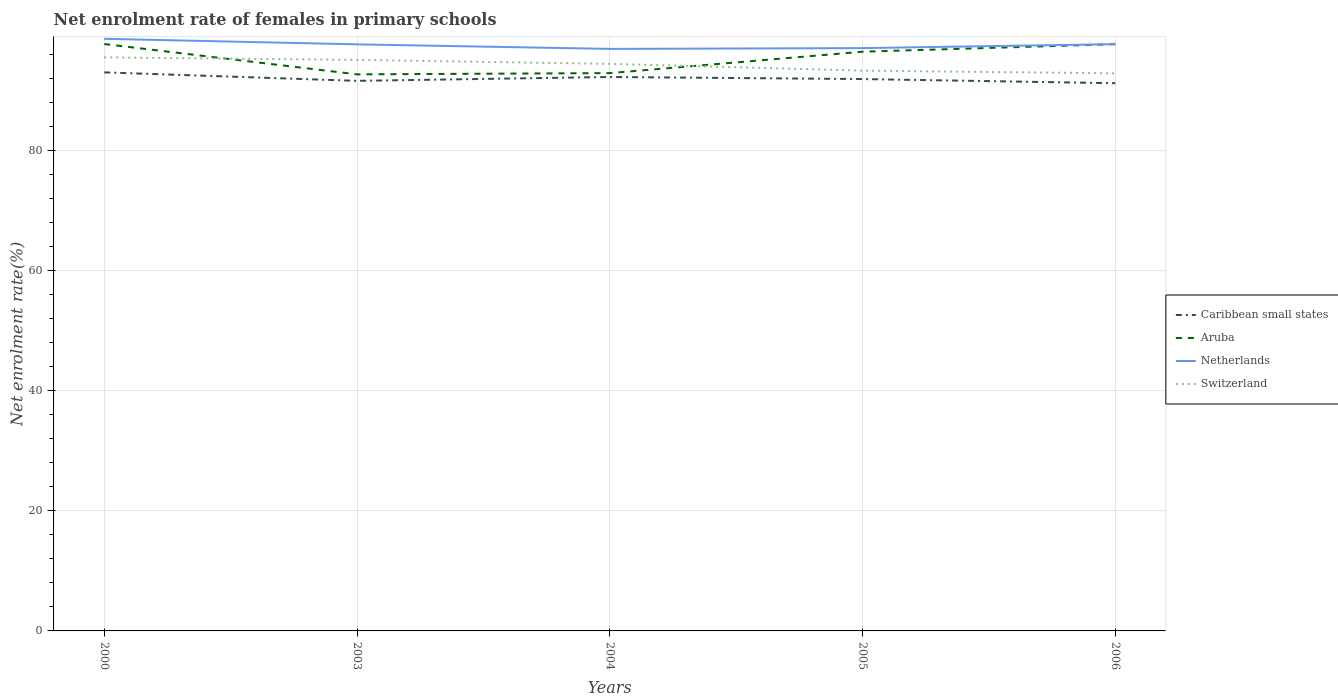Across all years, what is the maximum net enrolment rate of females in primary schools in Netherlands?
Provide a succinct answer. 97.01. What is the total net enrolment rate of females in primary schools in Switzerland in the graph?
Your response must be concise. 2.21. What is the difference between the highest and the second highest net enrolment rate of females in primary schools in Caribbean small states?
Your answer should be compact. 1.8. How many lines are there?
Ensure brevity in your answer.  4. What is the difference between two consecutive major ticks on the Y-axis?
Your answer should be very brief. 20. Are the values on the major ticks of Y-axis written in scientific E-notation?
Keep it short and to the point. No. Does the graph contain grids?
Keep it short and to the point. Yes. How many legend labels are there?
Provide a succinct answer. 4. How are the legend labels stacked?
Your answer should be very brief. Vertical. What is the title of the graph?
Provide a succinct answer. Net enrolment rate of females in primary schools. What is the label or title of the X-axis?
Make the answer very short. Years. What is the label or title of the Y-axis?
Make the answer very short. Net enrolment rate(%). What is the Net enrolment rate(%) of Caribbean small states in 2000?
Offer a terse response. 93.1. What is the Net enrolment rate(%) of Aruba in 2000?
Ensure brevity in your answer.  97.82. What is the Net enrolment rate(%) in Netherlands in 2000?
Provide a short and direct response. 98.69. What is the Net enrolment rate(%) of Switzerland in 2000?
Provide a succinct answer. 95.6. What is the Net enrolment rate(%) of Caribbean small states in 2003?
Keep it short and to the point. 91.69. What is the Net enrolment rate(%) of Aruba in 2003?
Your answer should be compact. 92.77. What is the Net enrolment rate(%) of Netherlands in 2003?
Your response must be concise. 97.77. What is the Net enrolment rate(%) in Switzerland in 2003?
Your answer should be very brief. 95.18. What is the Net enrolment rate(%) of Caribbean small states in 2004?
Keep it short and to the point. 92.33. What is the Net enrolment rate(%) in Aruba in 2004?
Your answer should be compact. 92.98. What is the Net enrolment rate(%) in Netherlands in 2004?
Provide a short and direct response. 97.01. What is the Net enrolment rate(%) of Switzerland in 2004?
Offer a very short reply. 94.52. What is the Net enrolment rate(%) of Caribbean small states in 2005?
Provide a short and direct response. 91.98. What is the Net enrolment rate(%) of Aruba in 2005?
Your answer should be very brief. 96.54. What is the Net enrolment rate(%) in Netherlands in 2005?
Provide a short and direct response. 97.14. What is the Net enrolment rate(%) of Switzerland in 2005?
Provide a short and direct response. 93.39. What is the Net enrolment rate(%) of Caribbean small states in 2006?
Offer a very short reply. 91.29. What is the Net enrolment rate(%) in Aruba in 2006?
Your response must be concise. 97.8. What is the Net enrolment rate(%) in Netherlands in 2006?
Offer a terse response. 97.8. What is the Net enrolment rate(%) of Switzerland in 2006?
Provide a short and direct response. 92.94. Across all years, what is the maximum Net enrolment rate(%) in Caribbean small states?
Give a very brief answer. 93.1. Across all years, what is the maximum Net enrolment rate(%) in Aruba?
Offer a terse response. 97.82. Across all years, what is the maximum Net enrolment rate(%) of Netherlands?
Ensure brevity in your answer.  98.69. Across all years, what is the maximum Net enrolment rate(%) in Switzerland?
Make the answer very short. 95.6. Across all years, what is the minimum Net enrolment rate(%) of Caribbean small states?
Make the answer very short. 91.29. Across all years, what is the minimum Net enrolment rate(%) of Aruba?
Your answer should be compact. 92.77. Across all years, what is the minimum Net enrolment rate(%) in Netherlands?
Ensure brevity in your answer.  97.01. Across all years, what is the minimum Net enrolment rate(%) in Switzerland?
Your response must be concise. 92.94. What is the total Net enrolment rate(%) in Caribbean small states in the graph?
Make the answer very short. 460.39. What is the total Net enrolment rate(%) of Aruba in the graph?
Your response must be concise. 477.91. What is the total Net enrolment rate(%) in Netherlands in the graph?
Make the answer very short. 488.42. What is the total Net enrolment rate(%) of Switzerland in the graph?
Offer a very short reply. 471.62. What is the difference between the Net enrolment rate(%) in Caribbean small states in 2000 and that in 2003?
Give a very brief answer. 1.41. What is the difference between the Net enrolment rate(%) in Aruba in 2000 and that in 2003?
Offer a very short reply. 5.05. What is the difference between the Net enrolment rate(%) of Netherlands in 2000 and that in 2003?
Offer a very short reply. 0.92. What is the difference between the Net enrolment rate(%) in Switzerland in 2000 and that in 2003?
Your response must be concise. 0.42. What is the difference between the Net enrolment rate(%) of Caribbean small states in 2000 and that in 2004?
Give a very brief answer. 0.77. What is the difference between the Net enrolment rate(%) in Aruba in 2000 and that in 2004?
Offer a terse response. 4.85. What is the difference between the Net enrolment rate(%) in Netherlands in 2000 and that in 2004?
Your answer should be very brief. 1.68. What is the difference between the Net enrolment rate(%) in Switzerland in 2000 and that in 2004?
Make the answer very short. 1.08. What is the difference between the Net enrolment rate(%) of Caribbean small states in 2000 and that in 2005?
Your response must be concise. 1.11. What is the difference between the Net enrolment rate(%) in Aruba in 2000 and that in 2005?
Ensure brevity in your answer.  1.28. What is the difference between the Net enrolment rate(%) in Netherlands in 2000 and that in 2005?
Ensure brevity in your answer.  1.55. What is the difference between the Net enrolment rate(%) in Switzerland in 2000 and that in 2005?
Offer a terse response. 2.21. What is the difference between the Net enrolment rate(%) of Caribbean small states in 2000 and that in 2006?
Ensure brevity in your answer.  1.8. What is the difference between the Net enrolment rate(%) in Aruba in 2000 and that in 2006?
Ensure brevity in your answer.  0.03. What is the difference between the Net enrolment rate(%) of Netherlands in 2000 and that in 2006?
Offer a very short reply. 0.89. What is the difference between the Net enrolment rate(%) in Switzerland in 2000 and that in 2006?
Provide a short and direct response. 2.66. What is the difference between the Net enrolment rate(%) of Caribbean small states in 2003 and that in 2004?
Your response must be concise. -0.64. What is the difference between the Net enrolment rate(%) of Aruba in 2003 and that in 2004?
Make the answer very short. -0.21. What is the difference between the Net enrolment rate(%) in Netherlands in 2003 and that in 2004?
Ensure brevity in your answer.  0.76. What is the difference between the Net enrolment rate(%) of Switzerland in 2003 and that in 2004?
Your answer should be compact. 0.66. What is the difference between the Net enrolment rate(%) of Caribbean small states in 2003 and that in 2005?
Make the answer very short. -0.3. What is the difference between the Net enrolment rate(%) in Aruba in 2003 and that in 2005?
Make the answer very short. -3.77. What is the difference between the Net enrolment rate(%) in Netherlands in 2003 and that in 2005?
Ensure brevity in your answer.  0.63. What is the difference between the Net enrolment rate(%) in Switzerland in 2003 and that in 2005?
Keep it short and to the point. 1.79. What is the difference between the Net enrolment rate(%) of Caribbean small states in 2003 and that in 2006?
Offer a terse response. 0.39. What is the difference between the Net enrolment rate(%) in Aruba in 2003 and that in 2006?
Provide a short and direct response. -5.03. What is the difference between the Net enrolment rate(%) of Netherlands in 2003 and that in 2006?
Make the answer very short. -0.03. What is the difference between the Net enrolment rate(%) in Switzerland in 2003 and that in 2006?
Make the answer very short. 2.24. What is the difference between the Net enrolment rate(%) of Caribbean small states in 2004 and that in 2005?
Your answer should be very brief. 0.35. What is the difference between the Net enrolment rate(%) of Aruba in 2004 and that in 2005?
Your response must be concise. -3.57. What is the difference between the Net enrolment rate(%) in Netherlands in 2004 and that in 2005?
Offer a very short reply. -0.13. What is the difference between the Net enrolment rate(%) of Switzerland in 2004 and that in 2005?
Offer a very short reply. 1.13. What is the difference between the Net enrolment rate(%) of Caribbean small states in 2004 and that in 2006?
Provide a short and direct response. 1.03. What is the difference between the Net enrolment rate(%) in Aruba in 2004 and that in 2006?
Make the answer very short. -4.82. What is the difference between the Net enrolment rate(%) in Netherlands in 2004 and that in 2006?
Your response must be concise. -0.79. What is the difference between the Net enrolment rate(%) in Switzerland in 2004 and that in 2006?
Provide a short and direct response. 1.58. What is the difference between the Net enrolment rate(%) in Caribbean small states in 2005 and that in 2006?
Offer a very short reply. 0.69. What is the difference between the Net enrolment rate(%) of Aruba in 2005 and that in 2006?
Give a very brief answer. -1.26. What is the difference between the Net enrolment rate(%) of Netherlands in 2005 and that in 2006?
Your answer should be very brief. -0.66. What is the difference between the Net enrolment rate(%) of Switzerland in 2005 and that in 2006?
Ensure brevity in your answer.  0.45. What is the difference between the Net enrolment rate(%) of Caribbean small states in 2000 and the Net enrolment rate(%) of Aruba in 2003?
Give a very brief answer. 0.33. What is the difference between the Net enrolment rate(%) in Caribbean small states in 2000 and the Net enrolment rate(%) in Netherlands in 2003?
Your answer should be very brief. -4.67. What is the difference between the Net enrolment rate(%) in Caribbean small states in 2000 and the Net enrolment rate(%) in Switzerland in 2003?
Offer a terse response. -2.08. What is the difference between the Net enrolment rate(%) of Aruba in 2000 and the Net enrolment rate(%) of Netherlands in 2003?
Keep it short and to the point. 0.05. What is the difference between the Net enrolment rate(%) in Aruba in 2000 and the Net enrolment rate(%) in Switzerland in 2003?
Your answer should be compact. 2.64. What is the difference between the Net enrolment rate(%) in Netherlands in 2000 and the Net enrolment rate(%) in Switzerland in 2003?
Ensure brevity in your answer.  3.52. What is the difference between the Net enrolment rate(%) of Caribbean small states in 2000 and the Net enrolment rate(%) of Aruba in 2004?
Offer a terse response. 0.12. What is the difference between the Net enrolment rate(%) of Caribbean small states in 2000 and the Net enrolment rate(%) of Netherlands in 2004?
Keep it short and to the point. -3.91. What is the difference between the Net enrolment rate(%) in Caribbean small states in 2000 and the Net enrolment rate(%) in Switzerland in 2004?
Your answer should be very brief. -1.42. What is the difference between the Net enrolment rate(%) in Aruba in 2000 and the Net enrolment rate(%) in Netherlands in 2004?
Keep it short and to the point. 0.81. What is the difference between the Net enrolment rate(%) of Aruba in 2000 and the Net enrolment rate(%) of Switzerland in 2004?
Your response must be concise. 3.31. What is the difference between the Net enrolment rate(%) of Netherlands in 2000 and the Net enrolment rate(%) of Switzerland in 2004?
Keep it short and to the point. 4.18. What is the difference between the Net enrolment rate(%) of Caribbean small states in 2000 and the Net enrolment rate(%) of Aruba in 2005?
Your answer should be compact. -3.44. What is the difference between the Net enrolment rate(%) of Caribbean small states in 2000 and the Net enrolment rate(%) of Netherlands in 2005?
Provide a succinct answer. -4.04. What is the difference between the Net enrolment rate(%) of Caribbean small states in 2000 and the Net enrolment rate(%) of Switzerland in 2005?
Provide a succinct answer. -0.29. What is the difference between the Net enrolment rate(%) of Aruba in 2000 and the Net enrolment rate(%) of Netherlands in 2005?
Keep it short and to the point. 0.68. What is the difference between the Net enrolment rate(%) of Aruba in 2000 and the Net enrolment rate(%) of Switzerland in 2005?
Your answer should be very brief. 4.44. What is the difference between the Net enrolment rate(%) of Netherlands in 2000 and the Net enrolment rate(%) of Switzerland in 2005?
Keep it short and to the point. 5.31. What is the difference between the Net enrolment rate(%) of Caribbean small states in 2000 and the Net enrolment rate(%) of Aruba in 2006?
Make the answer very short. -4.7. What is the difference between the Net enrolment rate(%) of Caribbean small states in 2000 and the Net enrolment rate(%) of Netherlands in 2006?
Make the answer very short. -4.7. What is the difference between the Net enrolment rate(%) in Caribbean small states in 2000 and the Net enrolment rate(%) in Switzerland in 2006?
Offer a terse response. 0.16. What is the difference between the Net enrolment rate(%) of Aruba in 2000 and the Net enrolment rate(%) of Netherlands in 2006?
Keep it short and to the point. 0.02. What is the difference between the Net enrolment rate(%) of Aruba in 2000 and the Net enrolment rate(%) of Switzerland in 2006?
Provide a succinct answer. 4.88. What is the difference between the Net enrolment rate(%) in Netherlands in 2000 and the Net enrolment rate(%) in Switzerland in 2006?
Give a very brief answer. 5.75. What is the difference between the Net enrolment rate(%) of Caribbean small states in 2003 and the Net enrolment rate(%) of Aruba in 2004?
Provide a short and direct response. -1.29. What is the difference between the Net enrolment rate(%) in Caribbean small states in 2003 and the Net enrolment rate(%) in Netherlands in 2004?
Ensure brevity in your answer.  -5.33. What is the difference between the Net enrolment rate(%) in Caribbean small states in 2003 and the Net enrolment rate(%) in Switzerland in 2004?
Provide a short and direct response. -2.83. What is the difference between the Net enrolment rate(%) in Aruba in 2003 and the Net enrolment rate(%) in Netherlands in 2004?
Keep it short and to the point. -4.24. What is the difference between the Net enrolment rate(%) of Aruba in 2003 and the Net enrolment rate(%) of Switzerland in 2004?
Give a very brief answer. -1.75. What is the difference between the Net enrolment rate(%) in Netherlands in 2003 and the Net enrolment rate(%) in Switzerland in 2004?
Offer a terse response. 3.25. What is the difference between the Net enrolment rate(%) in Caribbean small states in 2003 and the Net enrolment rate(%) in Aruba in 2005?
Your answer should be very brief. -4.86. What is the difference between the Net enrolment rate(%) of Caribbean small states in 2003 and the Net enrolment rate(%) of Netherlands in 2005?
Keep it short and to the point. -5.46. What is the difference between the Net enrolment rate(%) of Caribbean small states in 2003 and the Net enrolment rate(%) of Switzerland in 2005?
Keep it short and to the point. -1.7. What is the difference between the Net enrolment rate(%) in Aruba in 2003 and the Net enrolment rate(%) in Netherlands in 2005?
Your response must be concise. -4.37. What is the difference between the Net enrolment rate(%) in Aruba in 2003 and the Net enrolment rate(%) in Switzerland in 2005?
Offer a very short reply. -0.62. What is the difference between the Net enrolment rate(%) of Netherlands in 2003 and the Net enrolment rate(%) of Switzerland in 2005?
Provide a short and direct response. 4.38. What is the difference between the Net enrolment rate(%) of Caribbean small states in 2003 and the Net enrolment rate(%) of Aruba in 2006?
Give a very brief answer. -6.11. What is the difference between the Net enrolment rate(%) of Caribbean small states in 2003 and the Net enrolment rate(%) of Netherlands in 2006?
Provide a succinct answer. -6.12. What is the difference between the Net enrolment rate(%) in Caribbean small states in 2003 and the Net enrolment rate(%) in Switzerland in 2006?
Give a very brief answer. -1.25. What is the difference between the Net enrolment rate(%) of Aruba in 2003 and the Net enrolment rate(%) of Netherlands in 2006?
Give a very brief answer. -5.03. What is the difference between the Net enrolment rate(%) of Aruba in 2003 and the Net enrolment rate(%) of Switzerland in 2006?
Your response must be concise. -0.17. What is the difference between the Net enrolment rate(%) in Netherlands in 2003 and the Net enrolment rate(%) in Switzerland in 2006?
Offer a very short reply. 4.83. What is the difference between the Net enrolment rate(%) in Caribbean small states in 2004 and the Net enrolment rate(%) in Aruba in 2005?
Your answer should be very brief. -4.21. What is the difference between the Net enrolment rate(%) in Caribbean small states in 2004 and the Net enrolment rate(%) in Netherlands in 2005?
Make the answer very short. -4.81. What is the difference between the Net enrolment rate(%) of Caribbean small states in 2004 and the Net enrolment rate(%) of Switzerland in 2005?
Your answer should be very brief. -1.06. What is the difference between the Net enrolment rate(%) in Aruba in 2004 and the Net enrolment rate(%) in Netherlands in 2005?
Your answer should be very brief. -4.17. What is the difference between the Net enrolment rate(%) of Aruba in 2004 and the Net enrolment rate(%) of Switzerland in 2005?
Your answer should be very brief. -0.41. What is the difference between the Net enrolment rate(%) in Netherlands in 2004 and the Net enrolment rate(%) in Switzerland in 2005?
Ensure brevity in your answer.  3.62. What is the difference between the Net enrolment rate(%) in Caribbean small states in 2004 and the Net enrolment rate(%) in Aruba in 2006?
Offer a terse response. -5.47. What is the difference between the Net enrolment rate(%) of Caribbean small states in 2004 and the Net enrolment rate(%) of Netherlands in 2006?
Give a very brief answer. -5.47. What is the difference between the Net enrolment rate(%) in Caribbean small states in 2004 and the Net enrolment rate(%) in Switzerland in 2006?
Your response must be concise. -0.61. What is the difference between the Net enrolment rate(%) in Aruba in 2004 and the Net enrolment rate(%) in Netherlands in 2006?
Ensure brevity in your answer.  -4.83. What is the difference between the Net enrolment rate(%) in Aruba in 2004 and the Net enrolment rate(%) in Switzerland in 2006?
Offer a very short reply. 0.04. What is the difference between the Net enrolment rate(%) of Netherlands in 2004 and the Net enrolment rate(%) of Switzerland in 2006?
Your response must be concise. 4.07. What is the difference between the Net enrolment rate(%) in Caribbean small states in 2005 and the Net enrolment rate(%) in Aruba in 2006?
Your answer should be very brief. -5.81. What is the difference between the Net enrolment rate(%) of Caribbean small states in 2005 and the Net enrolment rate(%) of Netherlands in 2006?
Ensure brevity in your answer.  -5.82. What is the difference between the Net enrolment rate(%) of Caribbean small states in 2005 and the Net enrolment rate(%) of Switzerland in 2006?
Your answer should be very brief. -0.96. What is the difference between the Net enrolment rate(%) in Aruba in 2005 and the Net enrolment rate(%) in Netherlands in 2006?
Offer a very short reply. -1.26. What is the difference between the Net enrolment rate(%) of Aruba in 2005 and the Net enrolment rate(%) of Switzerland in 2006?
Give a very brief answer. 3.6. What is the difference between the Net enrolment rate(%) of Netherlands in 2005 and the Net enrolment rate(%) of Switzerland in 2006?
Give a very brief answer. 4.2. What is the average Net enrolment rate(%) of Caribbean small states per year?
Provide a succinct answer. 92.08. What is the average Net enrolment rate(%) in Aruba per year?
Offer a very short reply. 95.58. What is the average Net enrolment rate(%) in Netherlands per year?
Offer a very short reply. 97.68. What is the average Net enrolment rate(%) of Switzerland per year?
Give a very brief answer. 94.32. In the year 2000, what is the difference between the Net enrolment rate(%) of Caribbean small states and Net enrolment rate(%) of Aruba?
Your answer should be very brief. -4.73. In the year 2000, what is the difference between the Net enrolment rate(%) in Caribbean small states and Net enrolment rate(%) in Netherlands?
Keep it short and to the point. -5.6. In the year 2000, what is the difference between the Net enrolment rate(%) of Caribbean small states and Net enrolment rate(%) of Switzerland?
Provide a succinct answer. -2.5. In the year 2000, what is the difference between the Net enrolment rate(%) in Aruba and Net enrolment rate(%) in Netherlands?
Make the answer very short. -0.87. In the year 2000, what is the difference between the Net enrolment rate(%) of Aruba and Net enrolment rate(%) of Switzerland?
Give a very brief answer. 2.22. In the year 2000, what is the difference between the Net enrolment rate(%) of Netherlands and Net enrolment rate(%) of Switzerland?
Your answer should be compact. 3.1. In the year 2003, what is the difference between the Net enrolment rate(%) of Caribbean small states and Net enrolment rate(%) of Aruba?
Offer a very short reply. -1.08. In the year 2003, what is the difference between the Net enrolment rate(%) in Caribbean small states and Net enrolment rate(%) in Netherlands?
Ensure brevity in your answer.  -6.08. In the year 2003, what is the difference between the Net enrolment rate(%) in Caribbean small states and Net enrolment rate(%) in Switzerland?
Ensure brevity in your answer.  -3.49. In the year 2003, what is the difference between the Net enrolment rate(%) in Aruba and Net enrolment rate(%) in Netherlands?
Give a very brief answer. -5. In the year 2003, what is the difference between the Net enrolment rate(%) in Aruba and Net enrolment rate(%) in Switzerland?
Provide a short and direct response. -2.41. In the year 2003, what is the difference between the Net enrolment rate(%) of Netherlands and Net enrolment rate(%) of Switzerland?
Offer a very short reply. 2.59. In the year 2004, what is the difference between the Net enrolment rate(%) of Caribbean small states and Net enrolment rate(%) of Aruba?
Offer a terse response. -0.65. In the year 2004, what is the difference between the Net enrolment rate(%) of Caribbean small states and Net enrolment rate(%) of Netherlands?
Your answer should be very brief. -4.68. In the year 2004, what is the difference between the Net enrolment rate(%) in Caribbean small states and Net enrolment rate(%) in Switzerland?
Provide a succinct answer. -2.19. In the year 2004, what is the difference between the Net enrolment rate(%) in Aruba and Net enrolment rate(%) in Netherlands?
Keep it short and to the point. -4.04. In the year 2004, what is the difference between the Net enrolment rate(%) in Aruba and Net enrolment rate(%) in Switzerland?
Offer a terse response. -1.54. In the year 2004, what is the difference between the Net enrolment rate(%) in Netherlands and Net enrolment rate(%) in Switzerland?
Keep it short and to the point. 2.5. In the year 2005, what is the difference between the Net enrolment rate(%) of Caribbean small states and Net enrolment rate(%) of Aruba?
Make the answer very short. -4.56. In the year 2005, what is the difference between the Net enrolment rate(%) in Caribbean small states and Net enrolment rate(%) in Netherlands?
Make the answer very short. -5.16. In the year 2005, what is the difference between the Net enrolment rate(%) of Caribbean small states and Net enrolment rate(%) of Switzerland?
Provide a succinct answer. -1.4. In the year 2005, what is the difference between the Net enrolment rate(%) in Aruba and Net enrolment rate(%) in Netherlands?
Your answer should be compact. -0.6. In the year 2005, what is the difference between the Net enrolment rate(%) in Aruba and Net enrolment rate(%) in Switzerland?
Ensure brevity in your answer.  3.15. In the year 2005, what is the difference between the Net enrolment rate(%) of Netherlands and Net enrolment rate(%) of Switzerland?
Make the answer very short. 3.75. In the year 2006, what is the difference between the Net enrolment rate(%) in Caribbean small states and Net enrolment rate(%) in Aruba?
Provide a short and direct response. -6.5. In the year 2006, what is the difference between the Net enrolment rate(%) in Caribbean small states and Net enrolment rate(%) in Netherlands?
Your answer should be compact. -6.51. In the year 2006, what is the difference between the Net enrolment rate(%) in Caribbean small states and Net enrolment rate(%) in Switzerland?
Offer a very short reply. -1.65. In the year 2006, what is the difference between the Net enrolment rate(%) of Aruba and Net enrolment rate(%) of Netherlands?
Keep it short and to the point. -0. In the year 2006, what is the difference between the Net enrolment rate(%) in Aruba and Net enrolment rate(%) in Switzerland?
Give a very brief answer. 4.86. In the year 2006, what is the difference between the Net enrolment rate(%) in Netherlands and Net enrolment rate(%) in Switzerland?
Provide a succinct answer. 4.86. What is the ratio of the Net enrolment rate(%) of Caribbean small states in 2000 to that in 2003?
Give a very brief answer. 1.02. What is the ratio of the Net enrolment rate(%) in Aruba in 2000 to that in 2003?
Give a very brief answer. 1.05. What is the ratio of the Net enrolment rate(%) of Netherlands in 2000 to that in 2003?
Keep it short and to the point. 1.01. What is the ratio of the Net enrolment rate(%) in Switzerland in 2000 to that in 2003?
Your answer should be very brief. 1. What is the ratio of the Net enrolment rate(%) in Caribbean small states in 2000 to that in 2004?
Your answer should be very brief. 1.01. What is the ratio of the Net enrolment rate(%) in Aruba in 2000 to that in 2004?
Keep it short and to the point. 1.05. What is the ratio of the Net enrolment rate(%) in Netherlands in 2000 to that in 2004?
Your response must be concise. 1.02. What is the ratio of the Net enrolment rate(%) of Switzerland in 2000 to that in 2004?
Keep it short and to the point. 1.01. What is the ratio of the Net enrolment rate(%) of Caribbean small states in 2000 to that in 2005?
Your answer should be compact. 1.01. What is the ratio of the Net enrolment rate(%) of Aruba in 2000 to that in 2005?
Offer a very short reply. 1.01. What is the ratio of the Net enrolment rate(%) of Switzerland in 2000 to that in 2005?
Offer a very short reply. 1.02. What is the ratio of the Net enrolment rate(%) of Caribbean small states in 2000 to that in 2006?
Make the answer very short. 1.02. What is the ratio of the Net enrolment rate(%) in Aruba in 2000 to that in 2006?
Your answer should be compact. 1. What is the ratio of the Net enrolment rate(%) in Netherlands in 2000 to that in 2006?
Provide a succinct answer. 1.01. What is the ratio of the Net enrolment rate(%) of Switzerland in 2000 to that in 2006?
Keep it short and to the point. 1.03. What is the ratio of the Net enrolment rate(%) in Aruba in 2003 to that in 2004?
Your response must be concise. 1. What is the ratio of the Net enrolment rate(%) in Netherlands in 2003 to that in 2004?
Offer a very short reply. 1.01. What is the ratio of the Net enrolment rate(%) in Switzerland in 2003 to that in 2004?
Provide a succinct answer. 1.01. What is the ratio of the Net enrolment rate(%) in Caribbean small states in 2003 to that in 2005?
Your response must be concise. 1. What is the ratio of the Net enrolment rate(%) of Aruba in 2003 to that in 2005?
Keep it short and to the point. 0.96. What is the ratio of the Net enrolment rate(%) in Netherlands in 2003 to that in 2005?
Offer a terse response. 1.01. What is the ratio of the Net enrolment rate(%) in Switzerland in 2003 to that in 2005?
Offer a terse response. 1.02. What is the ratio of the Net enrolment rate(%) in Caribbean small states in 2003 to that in 2006?
Your answer should be very brief. 1. What is the ratio of the Net enrolment rate(%) of Aruba in 2003 to that in 2006?
Offer a very short reply. 0.95. What is the ratio of the Net enrolment rate(%) in Switzerland in 2003 to that in 2006?
Ensure brevity in your answer.  1.02. What is the ratio of the Net enrolment rate(%) in Caribbean small states in 2004 to that in 2005?
Ensure brevity in your answer.  1. What is the ratio of the Net enrolment rate(%) in Aruba in 2004 to that in 2005?
Provide a short and direct response. 0.96. What is the ratio of the Net enrolment rate(%) in Switzerland in 2004 to that in 2005?
Offer a very short reply. 1.01. What is the ratio of the Net enrolment rate(%) of Caribbean small states in 2004 to that in 2006?
Ensure brevity in your answer.  1.01. What is the ratio of the Net enrolment rate(%) in Aruba in 2004 to that in 2006?
Keep it short and to the point. 0.95. What is the ratio of the Net enrolment rate(%) of Caribbean small states in 2005 to that in 2006?
Provide a succinct answer. 1.01. What is the ratio of the Net enrolment rate(%) in Aruba in 2005 to that in 2006?
Offer a terse response. 0.99. What is the ratio of the Net enrolment rate(%) in Netherlands in 2005 to that in 2006?
Make the answer very short. 0.99. What is the ratio of the Net enrolment rate(%) of Switzerland in 2005 to that in 2006?
Offer a very short reply. 1. What is the difference between the highest and the second highest Net enrolment rate(%) in Caribbean small states?
Provide a short and direct response. 0.77. What is the difference between the highest and the second highest Net enrolment rate(%) in Aruba?
Give a very brief answer. 0.03. What is the difference between the highest and the second highest Net enrolment rate(%) in Netherlands?
Give a very brief answer. 0.89. What is the difference between the highest and the second highest Net enrolment rate(%) in Switzerland?
Your answer should be compact. 0.42. What is the difference between the highest and the lowest Net enrolment rate(%) of Caribbean small states?
Keep it short and to the point. 1.8. What is the difference between the highest and the lowest Net enrolment rate(%) in Aruba?
Your response must be concise. 5.05. What is the difference between the highest and the lowest Net enrolment rate(%) of Netherlands?
Offer a very short reply. 1.68. What is the difference between the highest and the lowest Net enrolment rate(%) in Switzerland?
Provide a succinct answer. 2.66. 